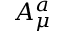Convert formula to latex. <formula><loc_0><loc_0><loc_500><loc_500>A _ { \mu } ^ { a }</formula> 